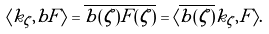Convert formula to latex. <formula><loc_0><loc_0><loc_500><loc_500>\langle k _ { \zeta } , b F \rangle = \overline { b ( \zeta ) F ( \zeta ) } = \langle \overline { b ( \zeta ) } k _ { \zeta } , F \rangle .</formula> 